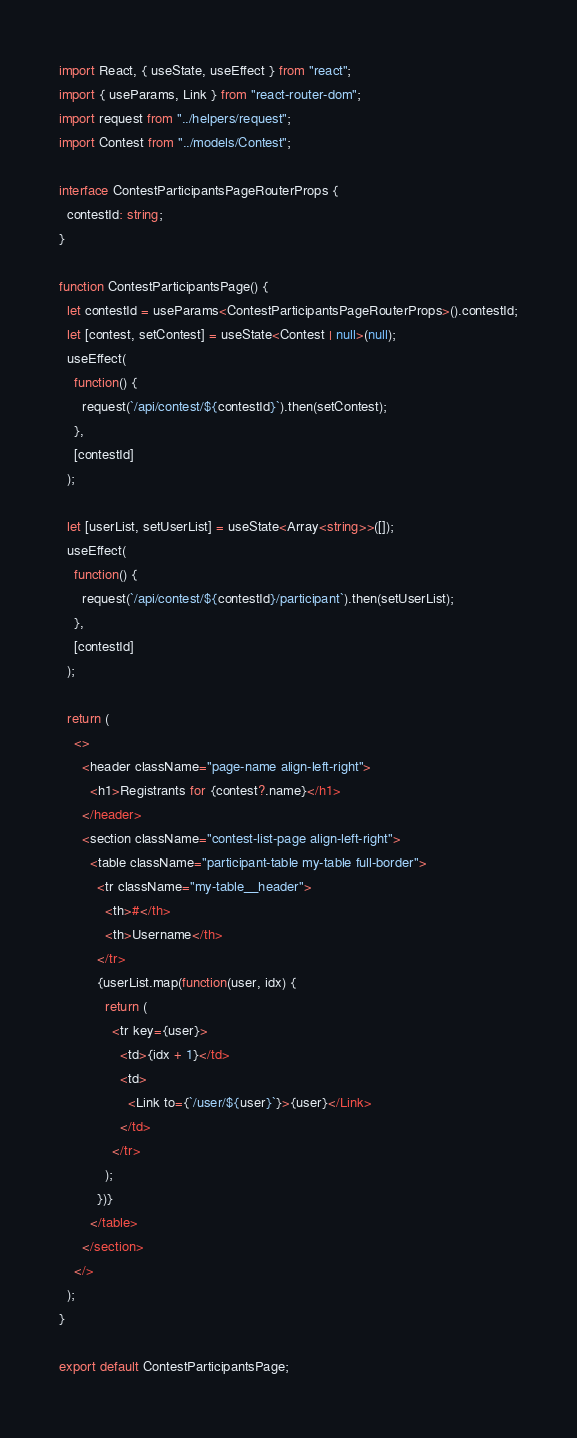Convert code to text. <code><loc_0><loc_0><loc_500><loc_500><_TypeScript_>import React, { useState, useEffect } from "react";
import { useParams, Link } from "react-router-dom";
import request from "../helpers/request";
import Contest from "../models/Contest";

interface ContestParticipantsPageRouterProps {
  contestId: string;
}

function ContestParticipantsPage() {
  let contestId = useParams<ContestParticipantsPageRouterProps>().contestId;
  let [contest, setContest] = useState<Contest | null>(null);
  useEffect(
    function() {
      request(`/api/contest/${contestId}`).then(setContest);
    },
    [contestId]
  );

  let [userList, setUserList] = useState<Array<string>>([]);
  useEffect(
    function() {
      request(`/api/contest/${contestId}/participant`).then(setUserList);
    },
    [contestId]
  );

  return (
    <>
      <header className="page-name align-left-right">
        <h1>Registrants for {contest?.name}</h1>
      </header>
      <section className="contest-list-page align-left-right">
        <table className="participant-table my-table full-border">
          <tr className="my-table__header">
            <th>#</th>
            <th>Username</th>
          </tr>
          {userList.map(function(user, idx) {
            return (
              <tr key={user}>
                <td>{idx + 1}</td>
                <td>
                  <Link to={`/user/${user}`}>{user}</Link>
                </td>
              </tr>
            );
          })}
        </table>
      </section>
    </>
  );
}

export default ContestParticipantsPage;
</code> 